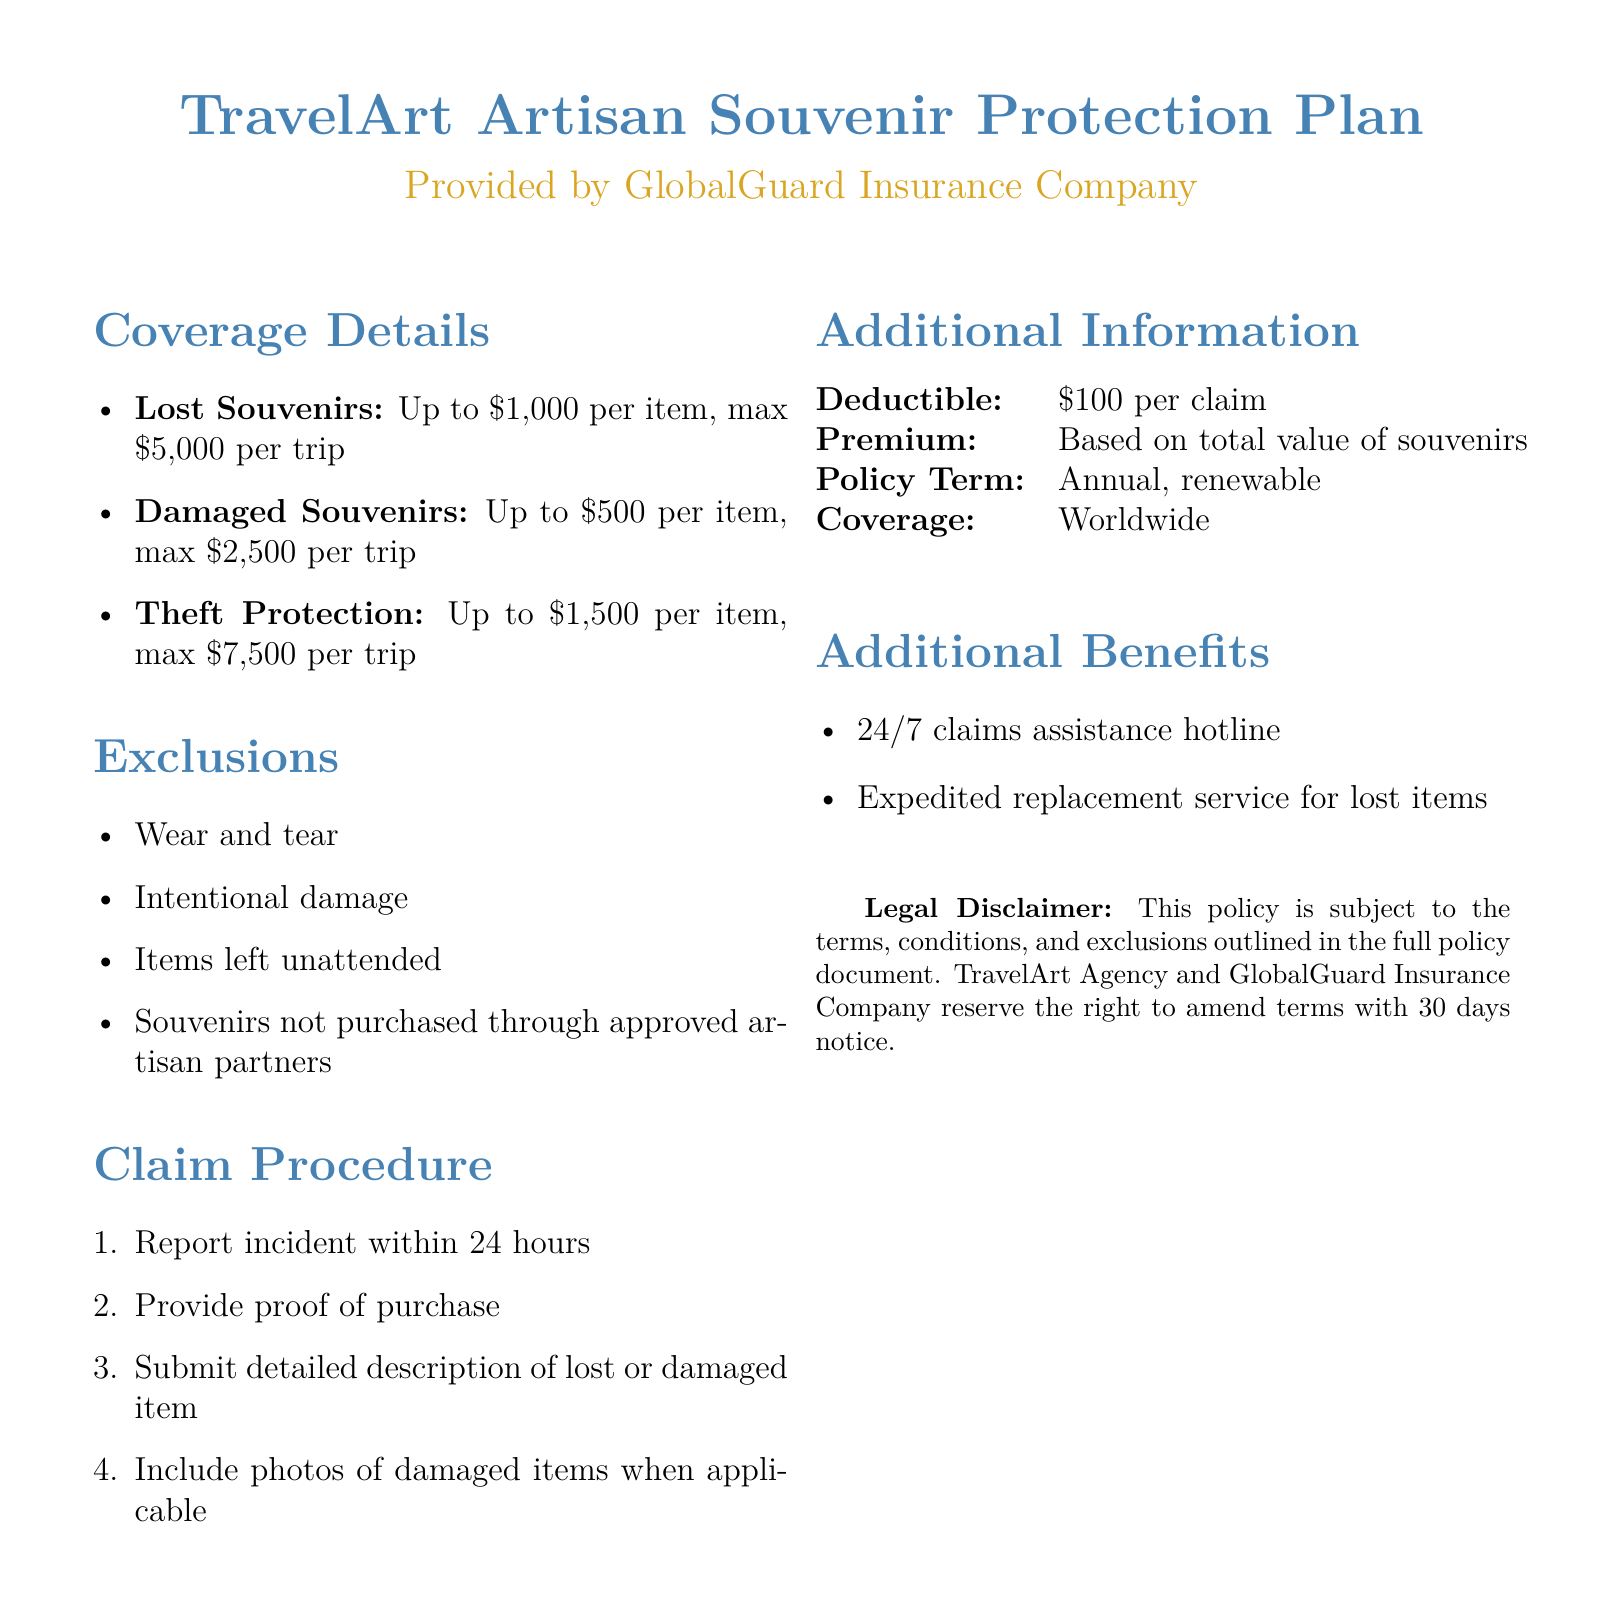what is the coverage for lost souvenirs? The coverage for lost souvenirs is detailed in the document as $1,000 per item, with a maximum of $5,000 per trip.
Answer: $1,000 per item, max $5,000 per trip what is the deductible amount? The deductible amount is specified in the document as the cost that needs to be paid by the claimant before insurance coverage kicks in.
Answer: $100 per claim what is the total coverage for damaged souvenirs per trip? The total coverage for damaged souvenirs is stated in the document, which includes the maximum coverage for a single trip.
Answer: $2,500 per trip which items are excluded from coverage? The document lists exclusions that specify the items or situations that are not covered under the policy.
Answer: Wear and tear, intentional damage, items left unattended, souvenirs not purchased through approved artisan partners what is the claim reporting time frame? The claim reporting time frame is indicated in the document, detailing the urgency required to report incidents for claims.
Answer: 24 hours what type of assistance is available for claims? The document mentions a specific service available for claims assistance, highlighting support structure.
Answer: 24/7 claims assistance hotline what is the maximum coverage amount for theft protection? The maximum coverage amount for theft protection is explicitly stated in the document, indicating what claims can be covered.
Answer: $1,500 per item, max $7,500 per trip how often can the policy be renewed? The document specifies the frequency at which the insurance policy can be renewed, which relates to its term.
Answer: Annual, renewable 